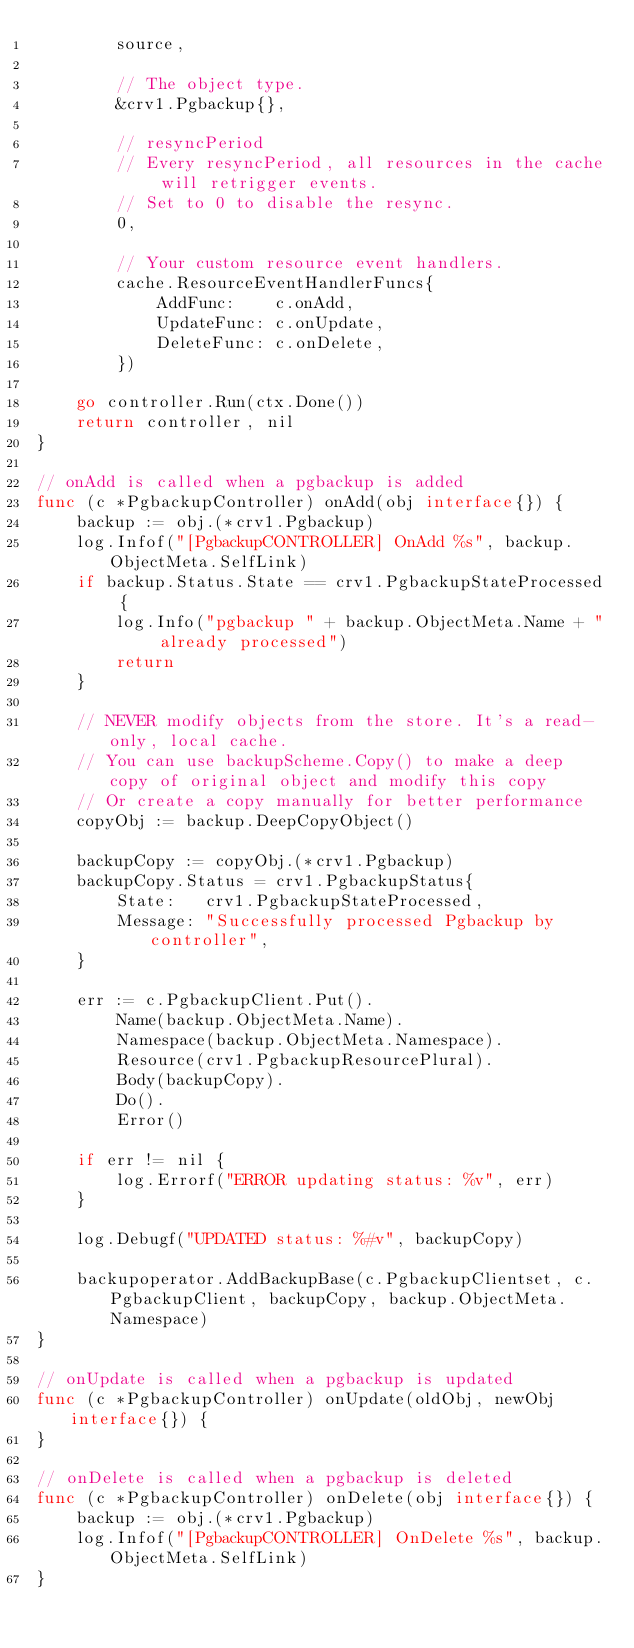Convert code to text. <code><loc_0><loc_0><loc_500><loc_500><_Go_>		source,

		// The object type.
		&crv1.Pgbackup{},

		// resyncPeriod
		// Every resyncPeriod, all resources in the cache will retrigger events.
		// Set to 0 to disable the resync.
		0,

		// Your custom resource event handlers.
		cache.ResourceEventHandlerFuncs{
			AddFunc:    c.onAdd,
			UpdateFunc: c.onUpdate,
			DeleteFunc: c.onDelete,
		})

	go controller.Run(ctx.Done())
	return controller, nil
}

// onAdd is called when a pgbackup is added
func (c *PgbackupController) onAdd(obj interface{}) {
	backup := obj.(*crv1.Pgbackup)
	log.Infof("[PgbackupCONTROLLER] OnAdd %s", backup.ObjectMeta.SelfLink)
	if backup.Status.State == crv1.PgbackupStateProcessed {
		log.Info("pgbackup " + backup.ObjectMeta.Name + " already processed")
		return
	}

	// NEVER modify objects from the store. It's a read-only, local cache.
	// You can use backupScheme.Copy() to make a deep copy of original object and modify this copy
	// Or create a copy manually for better performance
	copyObj := backup.DeepCopyObject()

	backupCopy := copyObj.(*crv1.Pgbackup)
	backupCopy.Status = crv1.PgbackupStatus{
		State:   crv1.PgbackupStateProcessed,
		Message: "Successfully processed Pgbackup by controller",
	}

	err := c.PgbackupClient.Put().
		Name(backup.ObjectMeta.Name).
		Namespace(backup.ObjectMeta.Namespace).
		Resource(crv1.PgbackupResourcePlural).
		Body(backupCopy).
		Do().
		Error()

	if err != nil {
		log.Errorf("ERROR updating status: %v", err)
	}

	log.Debugf("UPDATED status: %#v", backupCopy)

	backupoperator.AddBackupBase(c.PgbackupClientset, c.PgbackupClient, backupCopy, backup.ObjectMeta.Namespace)
}

// onUpdate is called when a pgbackup is updated
func (c *PgbackupController) onUpdate(oldObj, newObj interface{}) {
}

// onDelete is called when a pgbackup is deleted
func (c *PgbackupController) onDelete(obj interface{}) {
	backup := obj.(*crv1.Pgbackup)
	log.Infof("[PgbackupCONTROLLER] OnDelete %s", backup.ObjectMeta.SelfLink)
}
</code> 